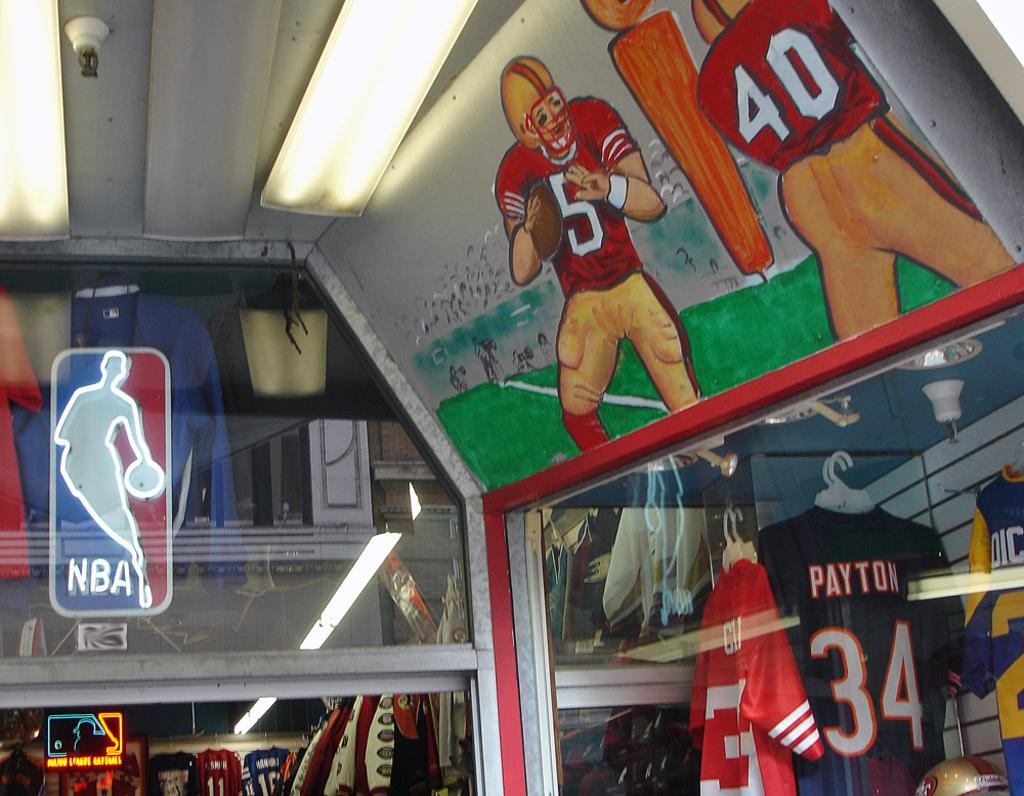<image>
Give a short and clear explanation of the subsequent image. An NBA sign is lit up behind a window above an open door. 